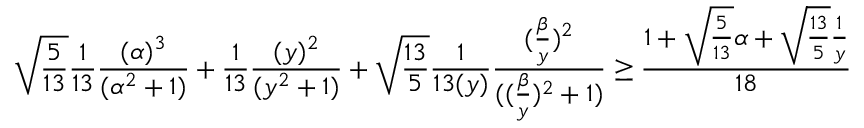Convert formula to latex. <formula><loc_0><loc_0><loc_500><loc_500>\sqrt { \frac { 5 } { 1 3 } } \frac { 1 } { 1 3 } \frac { ( \alpha ) ^ { 3 } } { ( \alpha ^ { 2 } + 1 ) } + \frac { 1 } { 1 3 } \frac { ( y ) ^ { 2 } } { ( y ^ { 2 } + 1 ) } + \sqrt { \frac { 1 3 } { 5 } } \frac { 1 } { 1 3 ( y ) } \frac { ( \frac { \beta } { y } ) ^ { 2 } } { ( ( \frac { \beta } { y } ) ^ { 2 } + 1 ) } \geq \frac { 1 + \sqrt { \frac { 5 } { 1 3 } } \alpha + \sqrt { \frac { 1 3 } { 5 } } \frac { 1 } { y } } { 1 8 }</formula> 